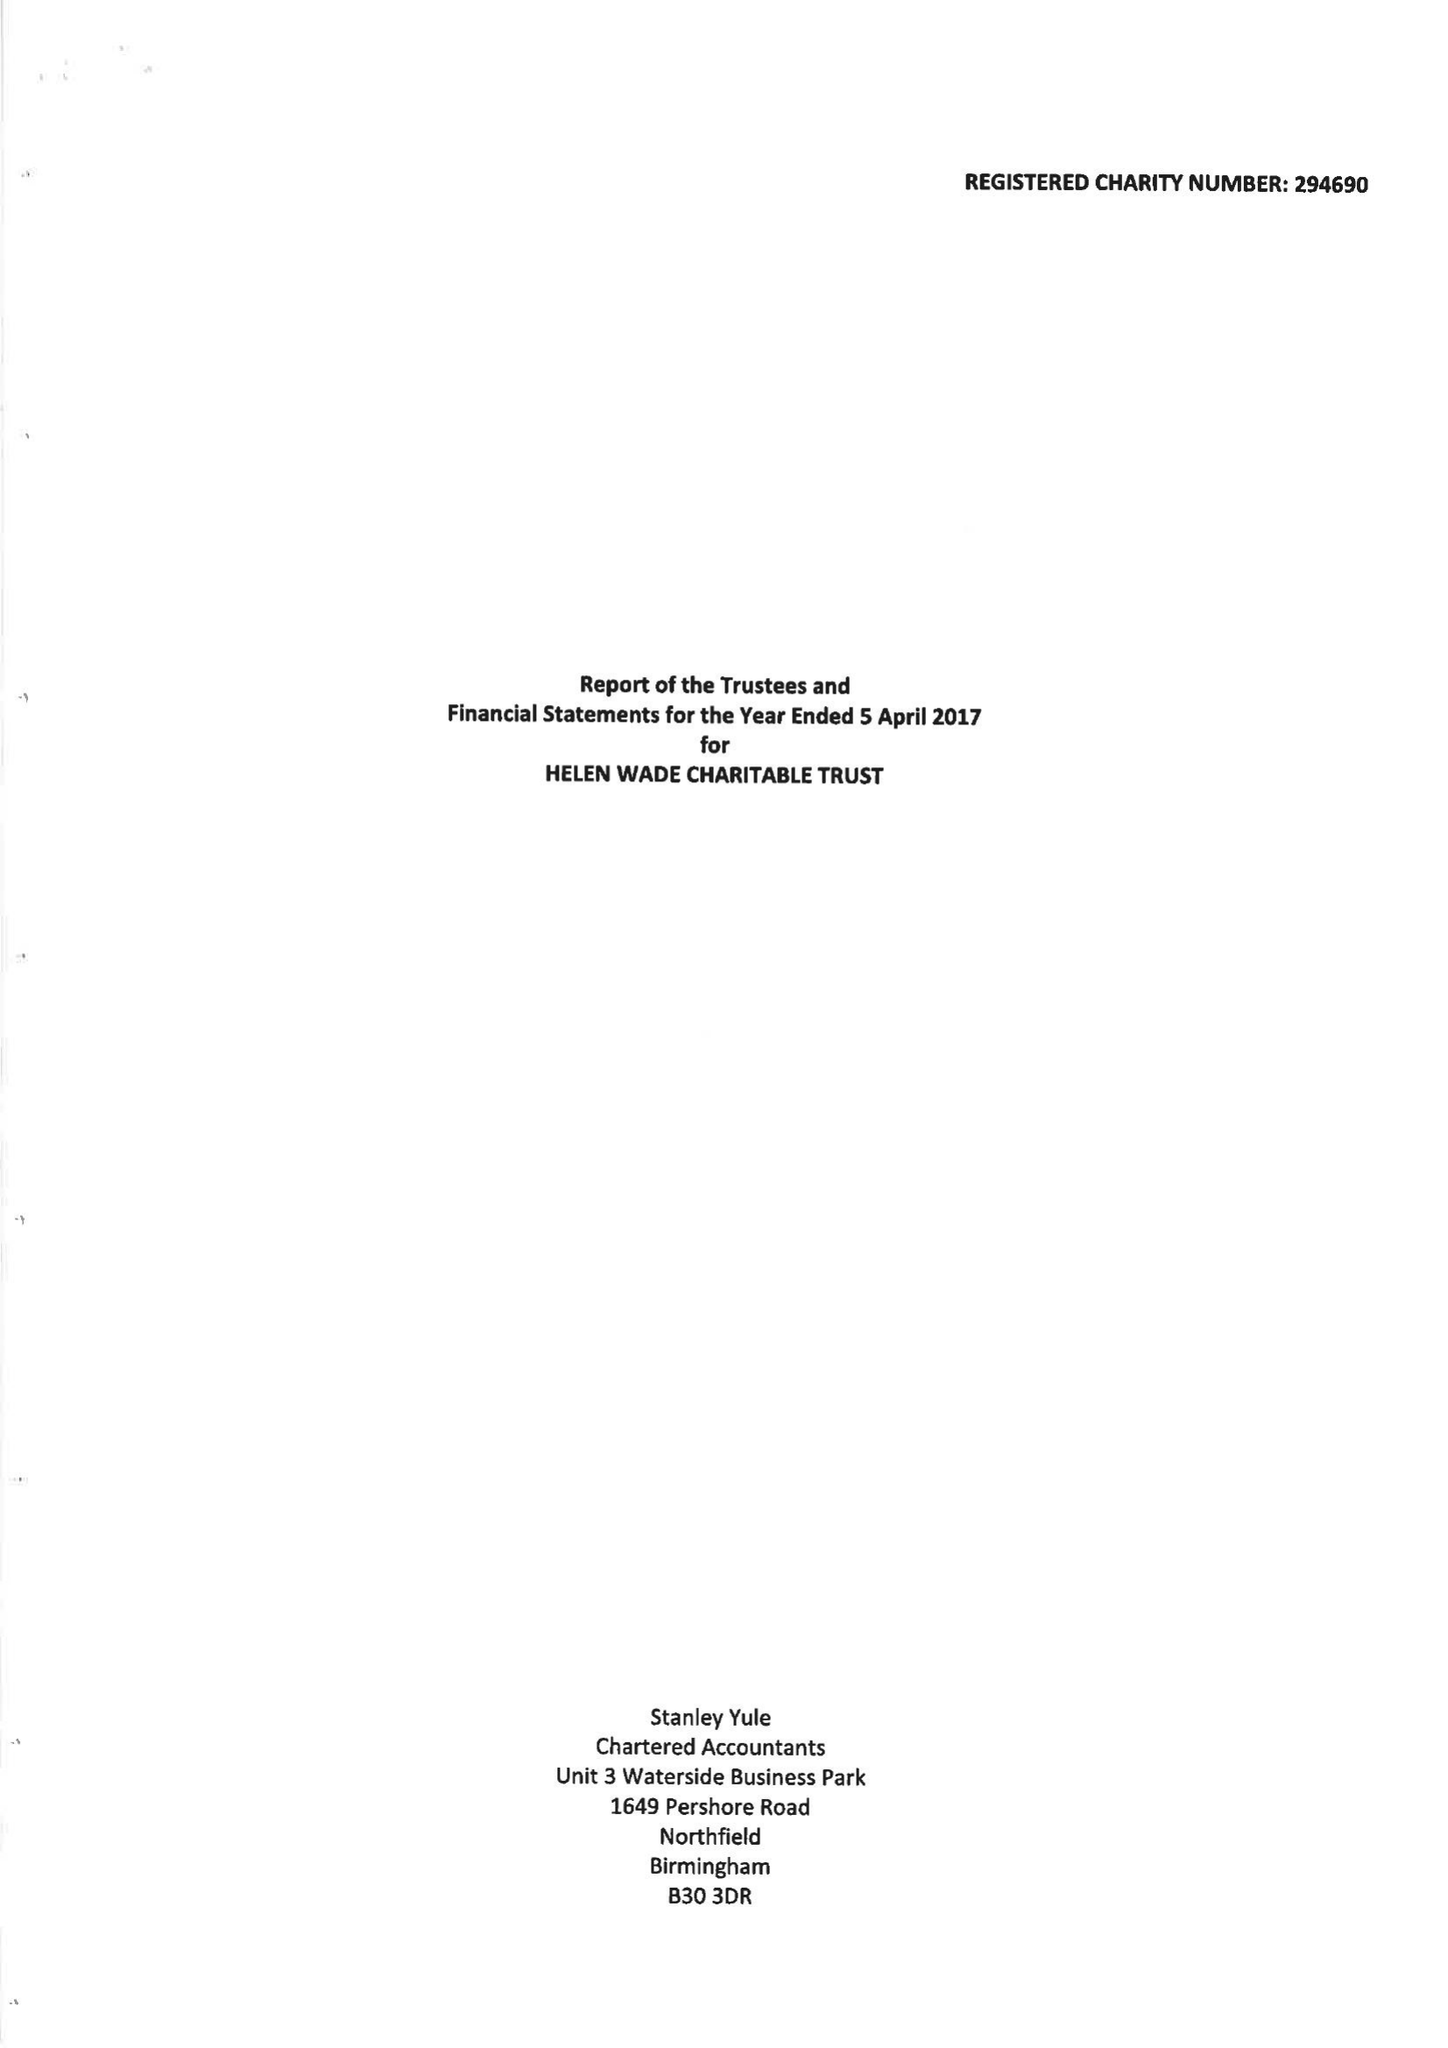What is the value for the address__postcode?
Answer the question using a single word or phrase. TN4 8AS 